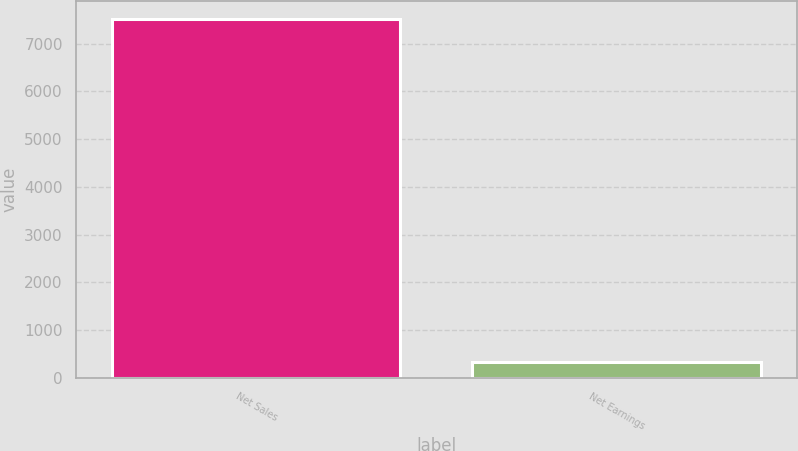Convert chart. <chart><loc_0><loc_0><loc_500><loc_500><bar_chart><fcel>Net Sales<fcel>Net Earnings<nl><fcel>7517.7<fcel>327.4<nl></chart> 